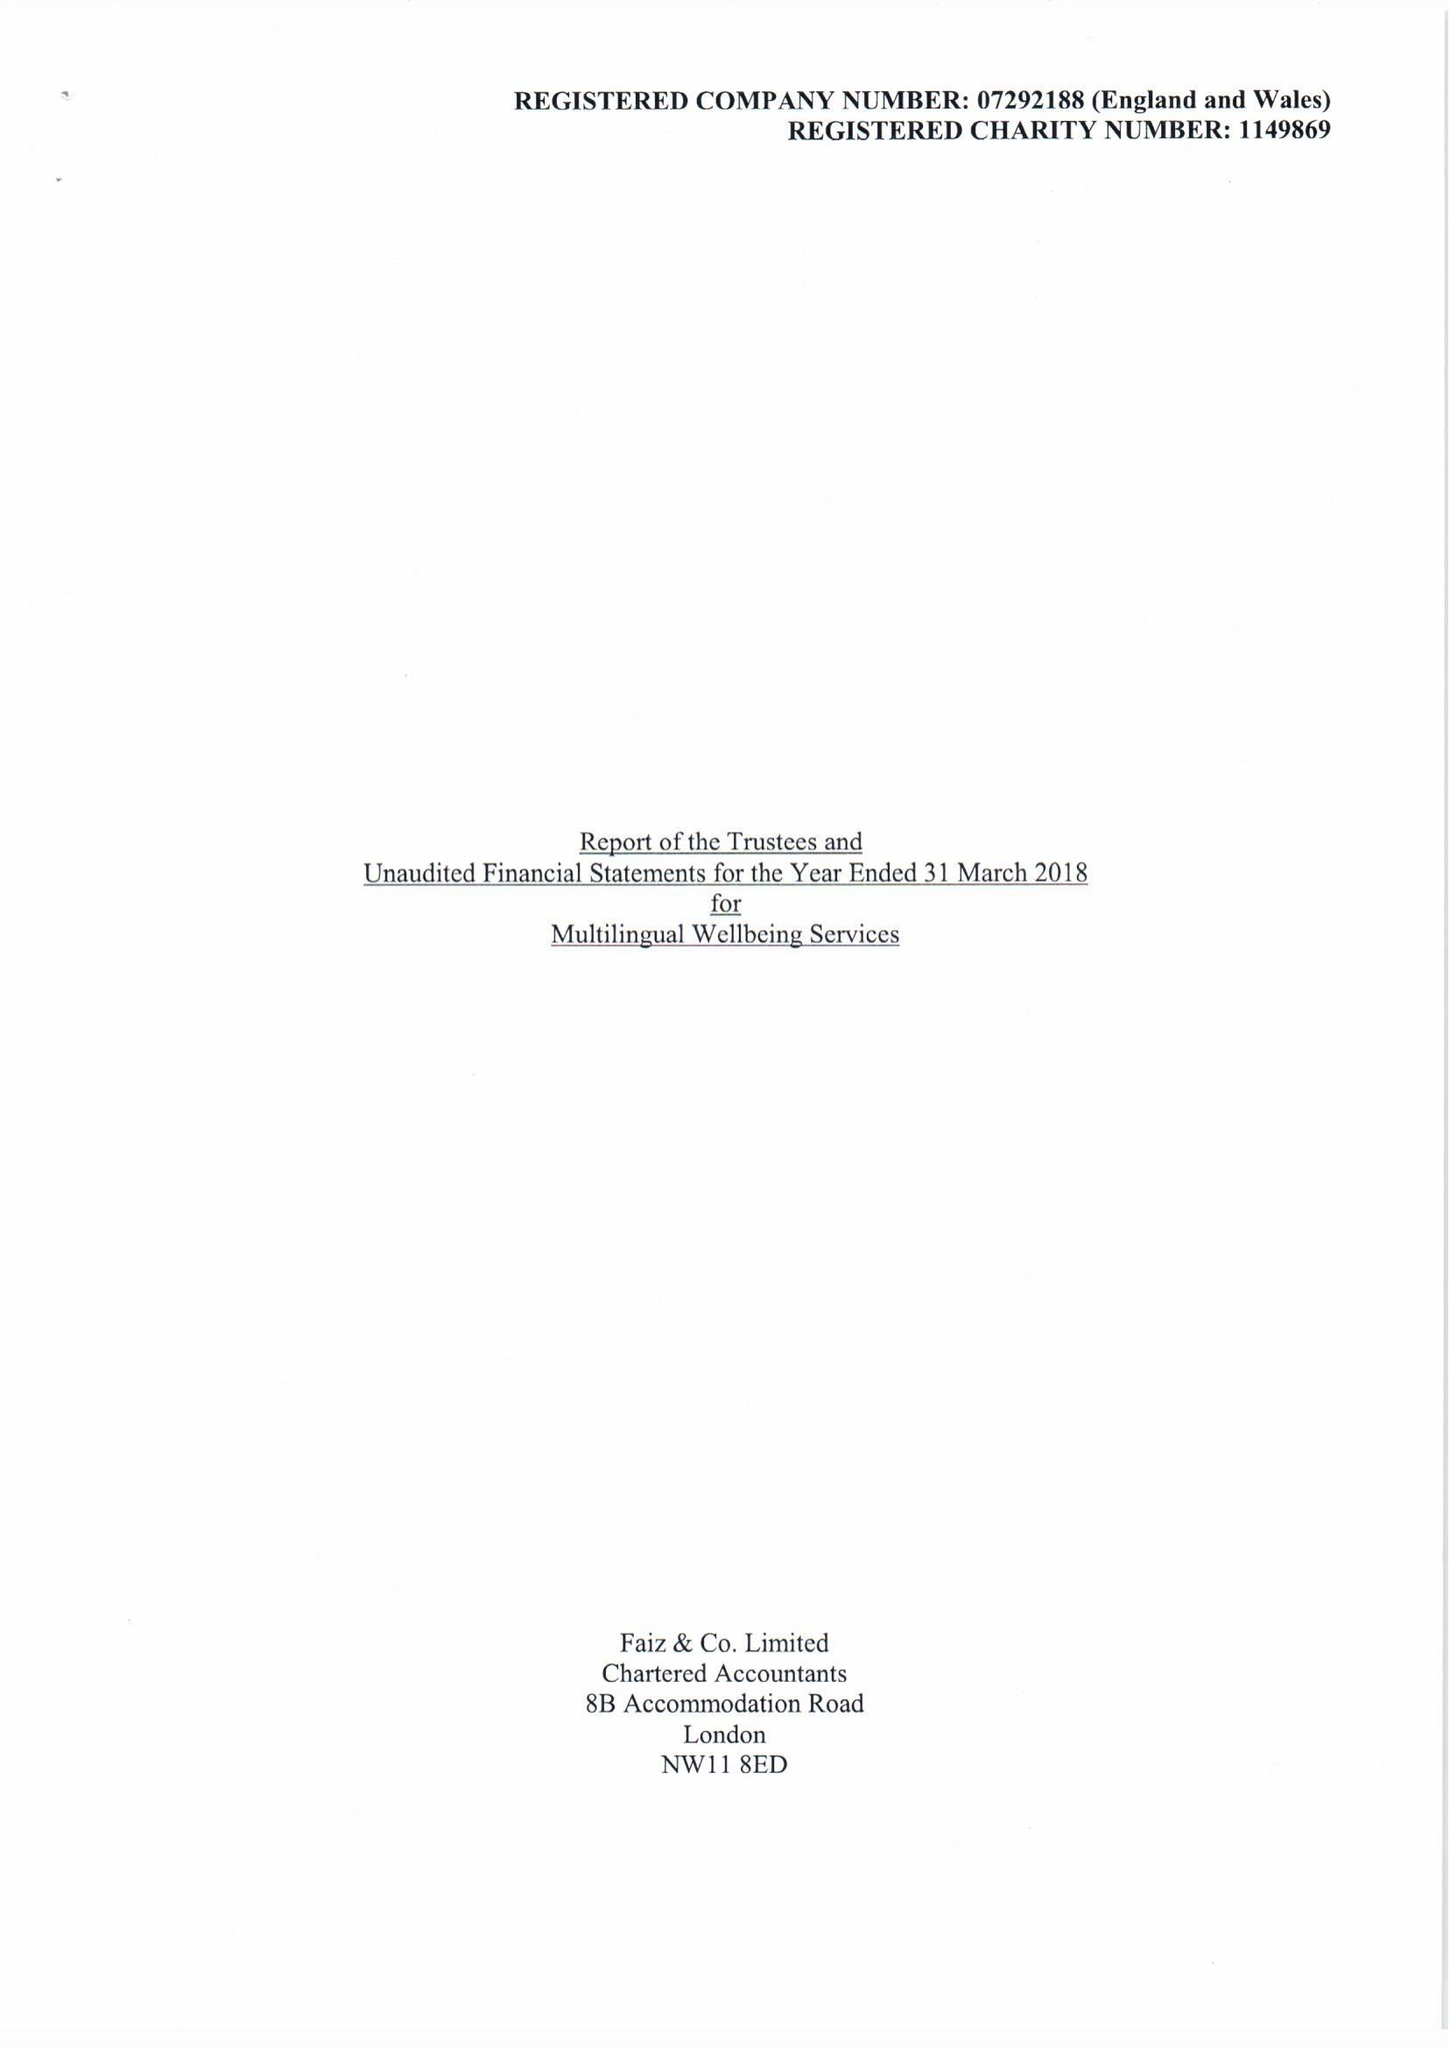What is the value for the report_date?
Answer the question using a single word or phrase. 2018-03-31 